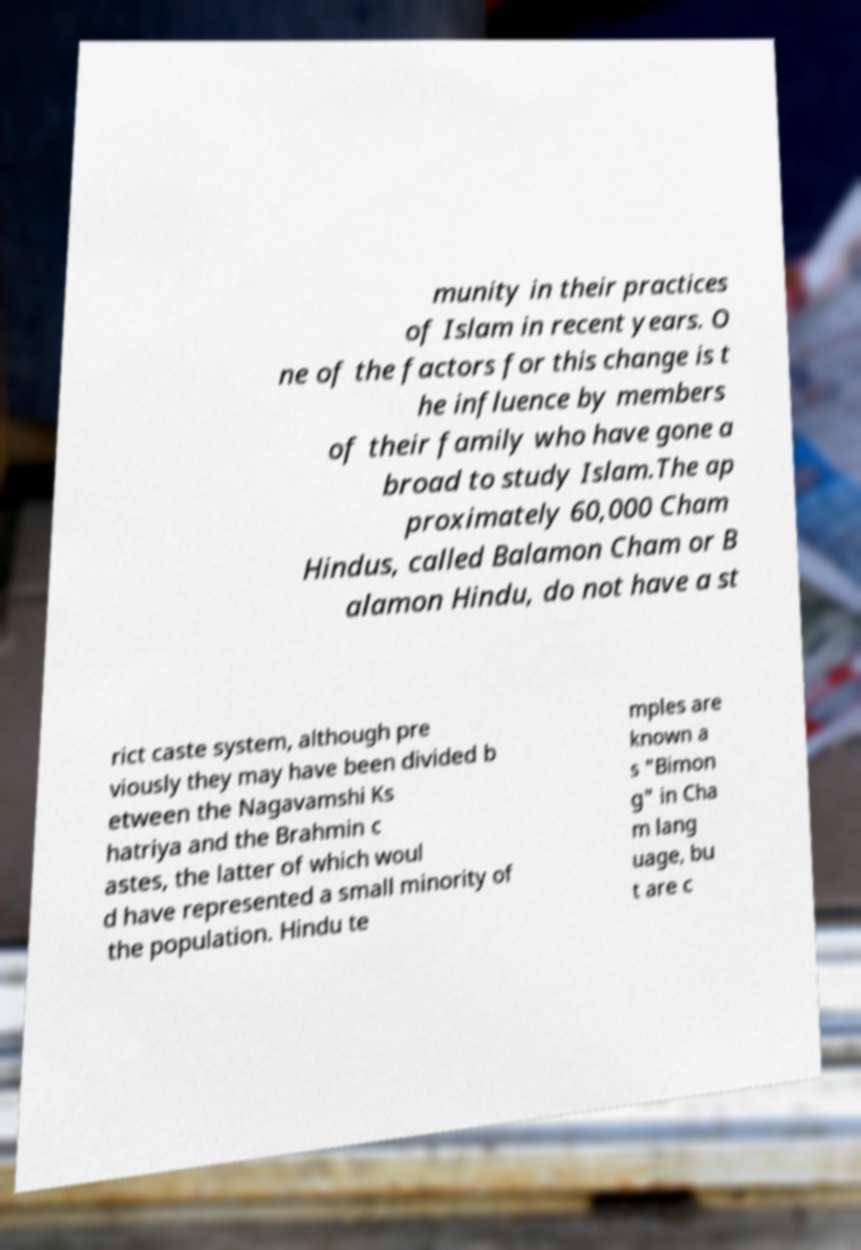Please read and relay the text visible in this image. What does it say? munity in their practices of Islam in recent years. O ne of the factors for this change is t he influence by members of their family who have gone a broad to study Islam.The ap proximately 60,000 Cham Hindus, called Balamon Cham or B alamon Hindu, do not have a st rict caste system, although pre viously they may have been divided b etween the Nagavamshi Ks hatriya and the Brahmin c astes, the latter of which woul d have represented a small minority of the population. Hindu te mples are known a s "Bimon g" in Cha m lang uage, bu t are c 